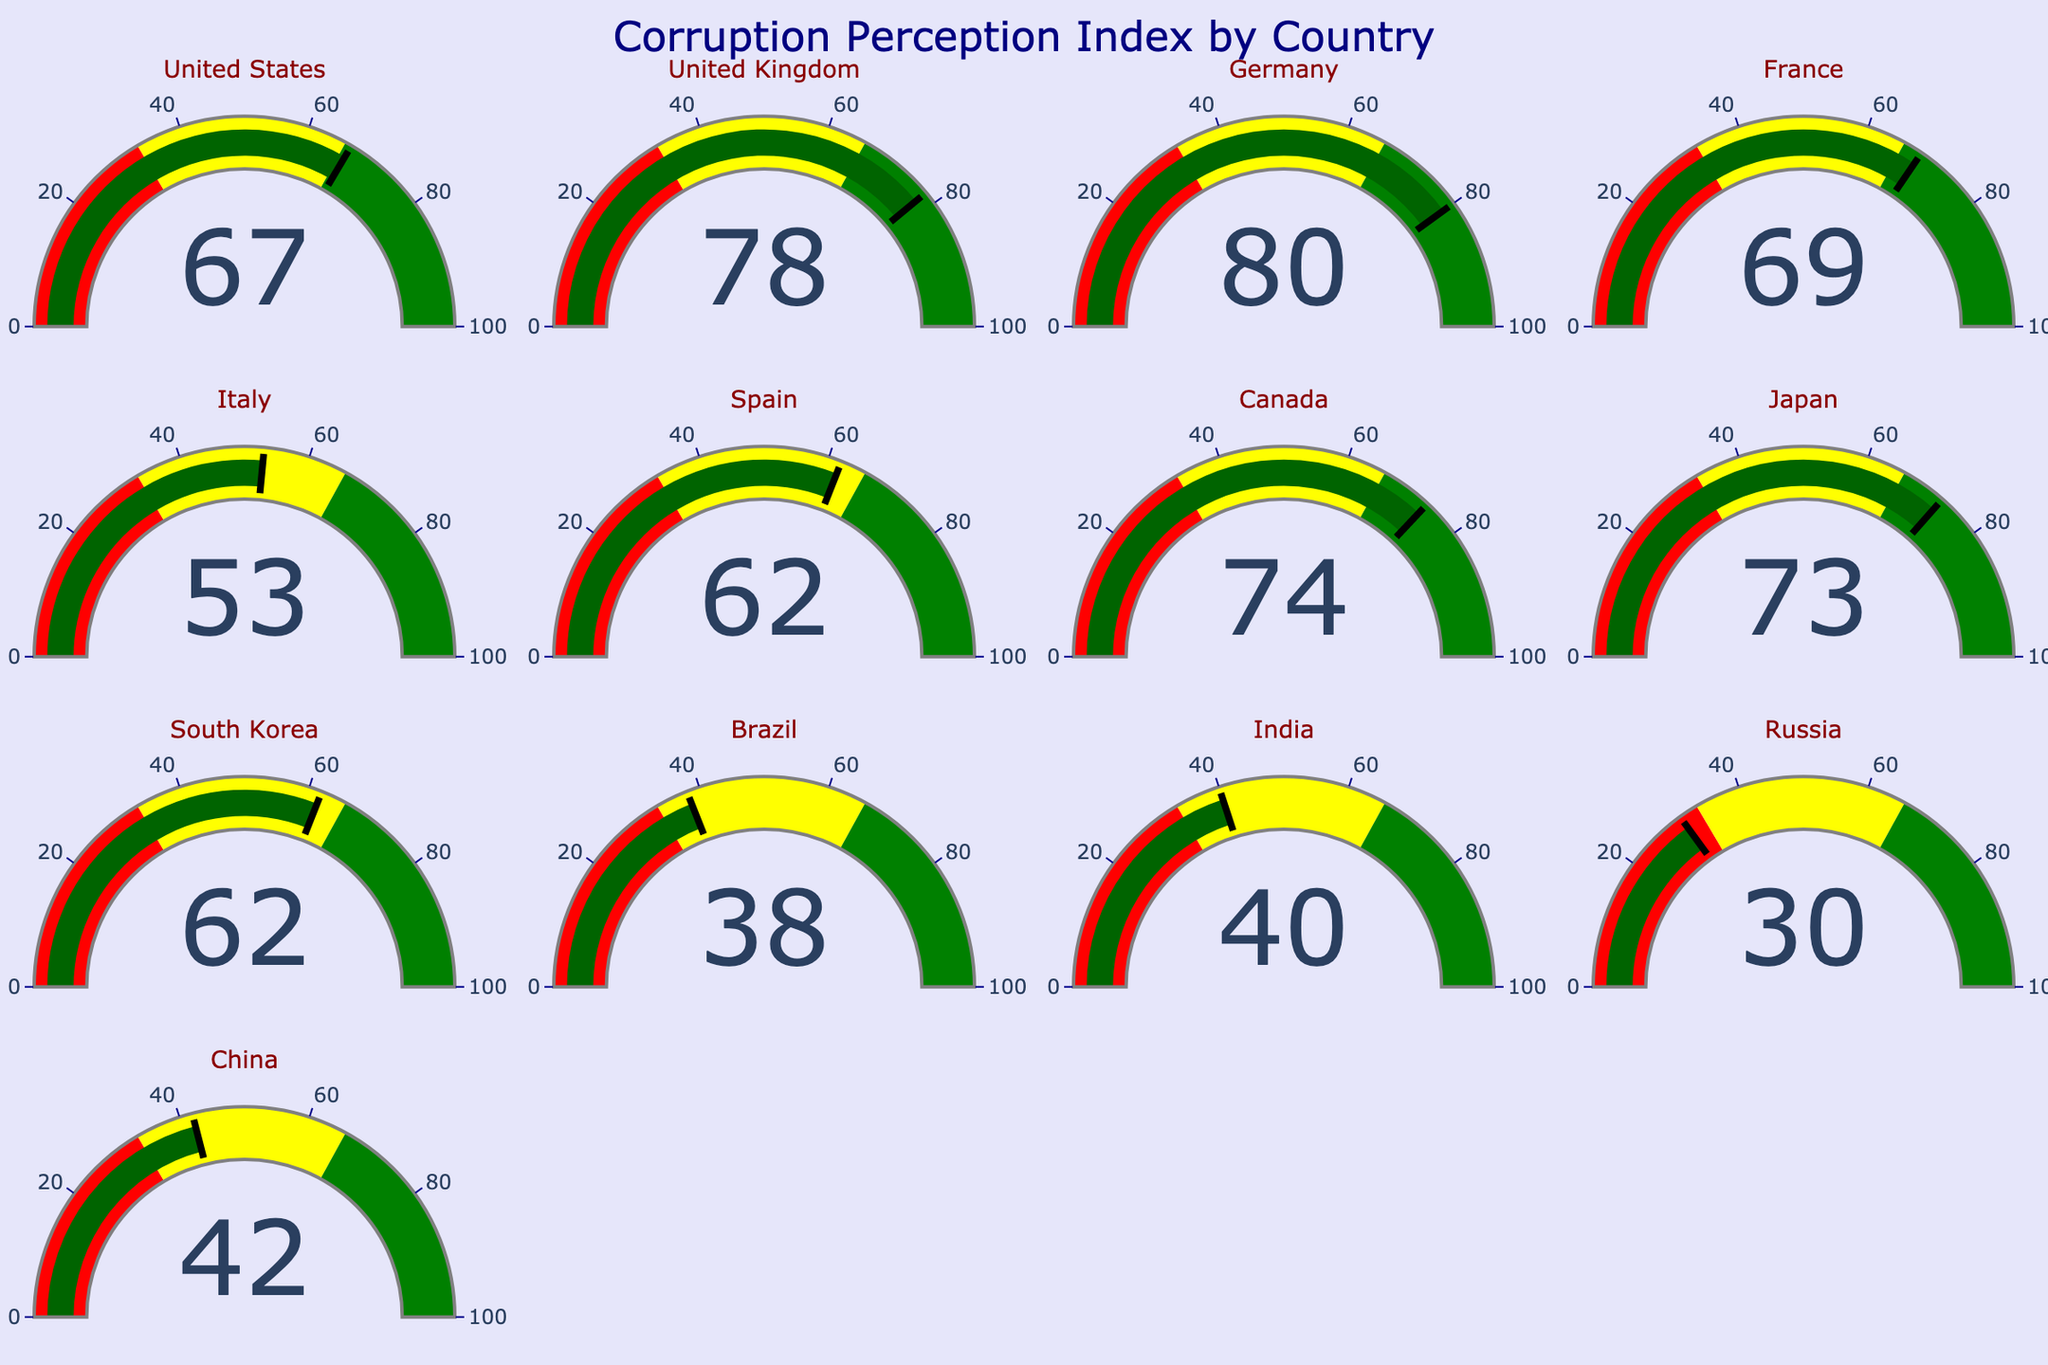What is the Corruption Perception Index of Germany? Look for the gauge labeled "Germany" and read the numerical value indicated.
Answer: 80 Which country has the lowest Corruption Perception Index? Compare all the numerical values shown in the gauges and find the smallest number. Russia's gauge shows 30, which is the lowest.
Answer: Russia What is the total Corruption Perception Index of the United States and the United Kingdom? Add the Corruption Perception Index of the United States (67) and the United Kingdom (78). The sum is 67 + 78 = 145.
Answer: 145 How many countries have a Corruption Perception Index above 70? Count the gauges with values greater than 70. The United Kingdom (78), Germany (80), France (69), Canada (74), and Japan (73) fit this criterion, making a total of 5.
Answer: 5 Is the Corruption Perception Index of Spain closer to that of Japan or South Korea? Calculate the absolute difference between Spain (62) and both Japan (73) and South Korea (62). The difference with Japan is 73 - 62 = 11, and the difference with South Korea is 62 - 62 = 0. Thus, it is closer to South Korea.
Answer: South Korea Which country has a higher Corruption Perception Index: Brazil or India? Compare the values for Brazil (38) and India (40). India has a higher value than Brazil.
Answer: India What is the median Corruption Perception Index of all the countries? Arrange the values in ascending order and find the middle number. Values: 30, 38, 40, 42, 53, 62, 62, 67, 69, 73, 74, 78, 80. The middle value in this sequence is 62.
Answer: 62 Which country has the closest Corruption Perception Index to 50? Calculate the absolute difference of each country's index to 50 and find the smallest difference. Italy has the closest with a value of 53, giving a difference of 3.
Answer: Italy What range of values are in the red zone? Note that the gauge chart has color-coded zones. The red zone is from 0 to 33.
Answer: 0 to 33 